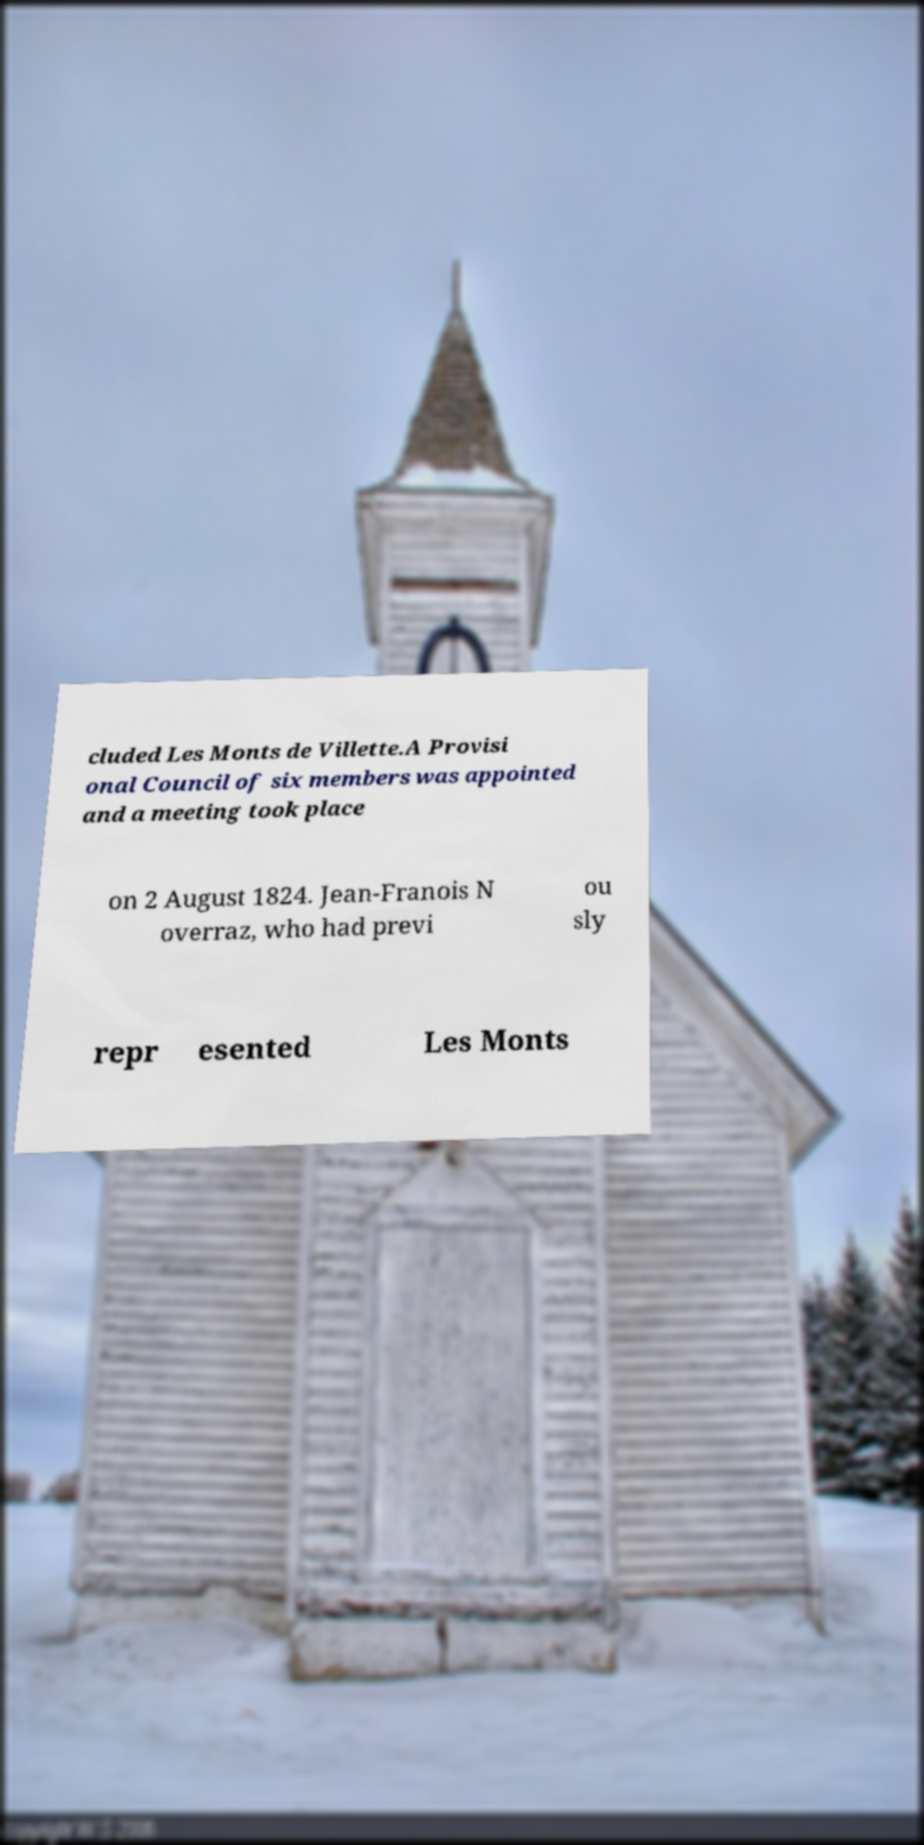I need the written content from this picture converted into text. Can you do that? cluded Les Monts de Villette.A Provisi onal Council of six members was appointed and a meeting took place on 2 August 1824. Jean-Franois N overraz, who had previ ou sly repr esented Les Monts 